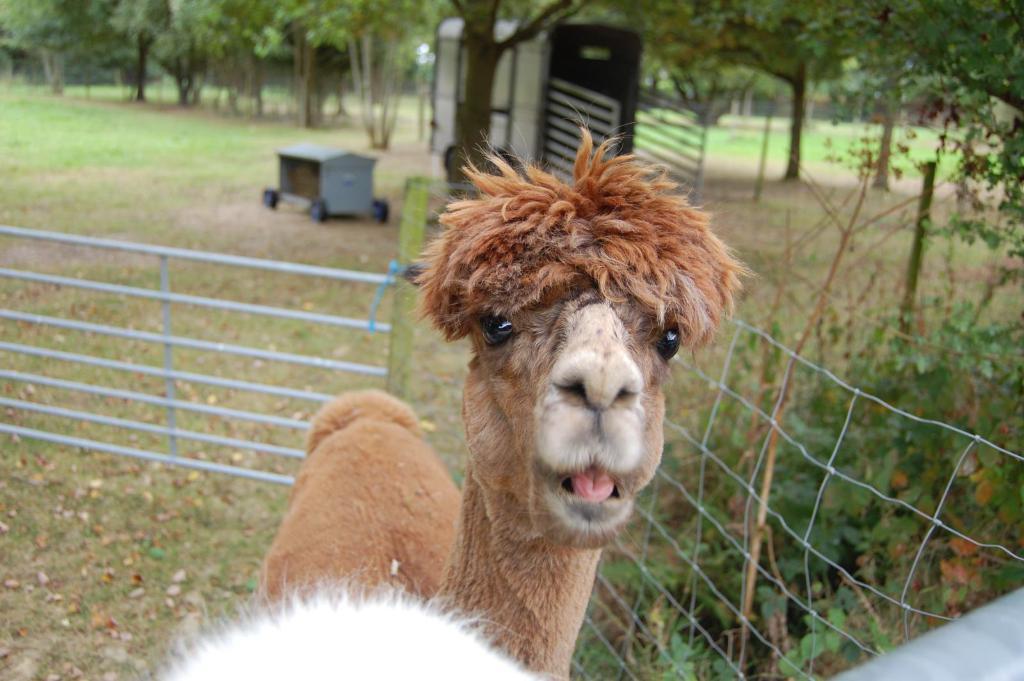Describe this image in one or two sentences. In this image we can see an animal. We can also see some grass, fence, pole, a trolley, the bark of a tree and a truck on the ground. On the backside we can a group of trees. 